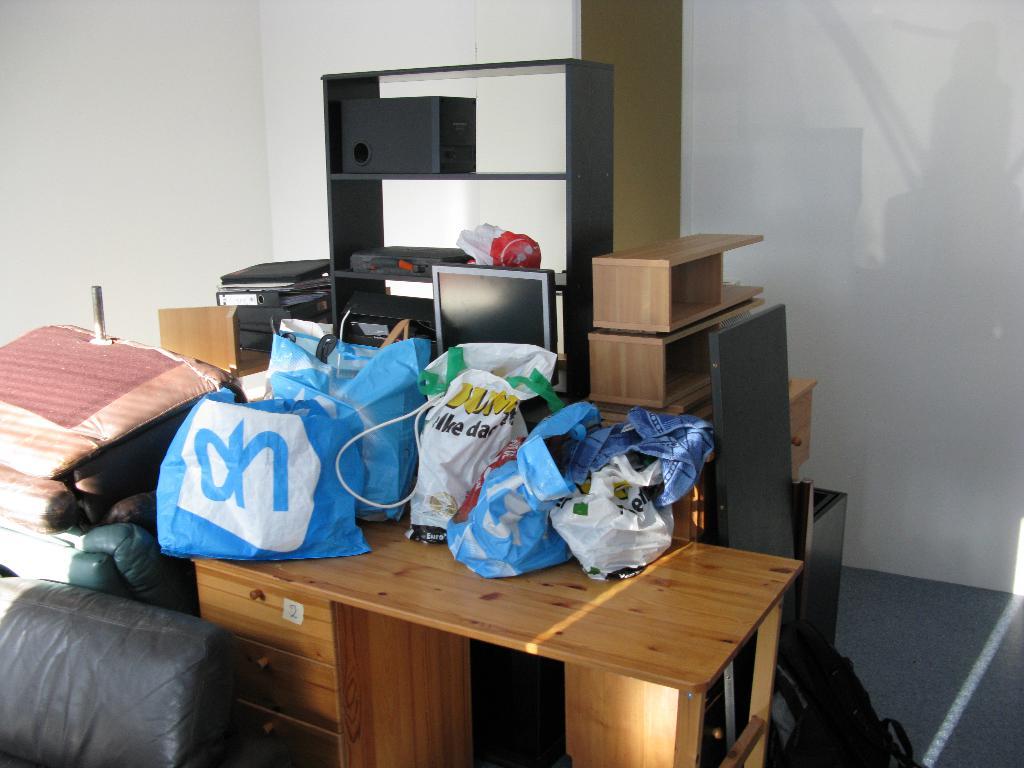What is on that bag?
Your answer should be compact. Oh. 